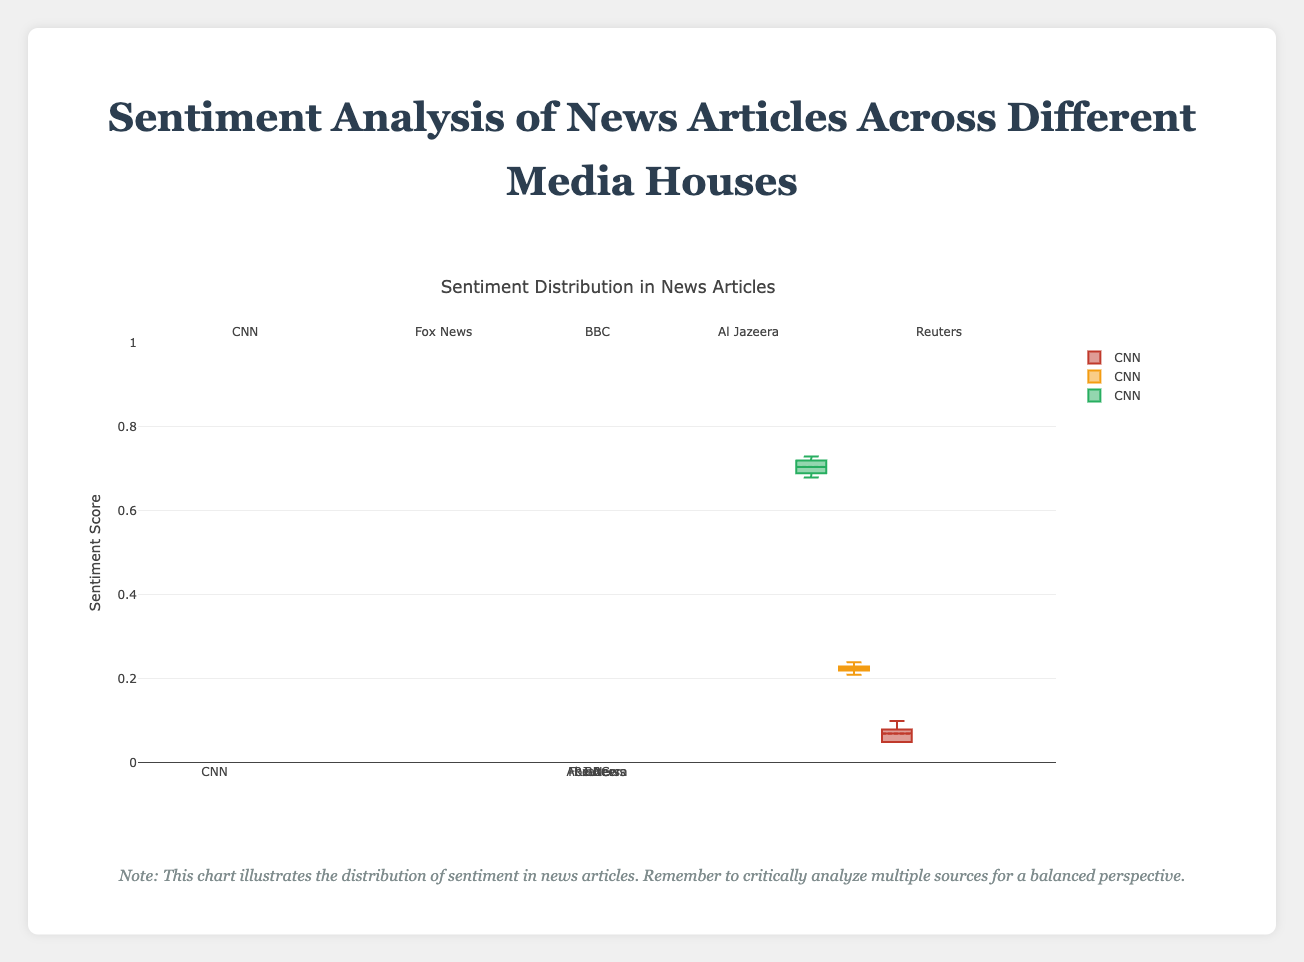What does the title of the chart indicate? The title of the chart is "Sentiment Analysis of News Articles Across Different Media Houses." This indicates that the chart shows the distribution of sentiment (positive, neutral, negative) in news articles from different media houses.
Answer: Sentiment Analysis of News Articles Across Different Media Houses What do the colors green, orange, and red represent in the box plot? In the box plot, the colors represent different sentiments: green represents positive sentiment, orange represents neutral sentiment, and red represents negative sentiment.
Answer: Positive, Neutral, Negative Which media house has the highest median positive sentiment score? To determine the highest median positive sentiment score, look at the middle line inside the green boxes for each media house. Reuters has the highest median positive sentiment score, as its middle line is the highest among all the green boxes.
Answer: Reuters Which media house has the widest range of negative sentiment scores? To find the widest range of negative sentiment scores, compare the length of the red boxes. CNN has the widest range as its red box spans a broader area than other media houses.
Answer: CNN How does the median neutral sentiment score for Fox News compare to CNN? Look at the middle line inside the orange boxes for both Fox News and CNN. The middle line (median) for Fox News’s neutral sentiment is slightly lower than CNN’s.
Answer: Fox News's median is lower What is the interquartile range (IQR) of positive sentiment scores for BBC? The IQR is the range between the first quartile (bottom of the box) and the third quartile (top of the box). For BBC's positive sentiment, the box plot extends from around 0.68 to 0.71. The IQR is 0.71 - 0.68 = 0.03.
Answer: 0.03 Which media house shows the least variability in neutral sentiment scores? Look for the shortest box in the orange category, which indicates less variability. Reuters shows the least variability in neutral sentiment scores as its orange box is the shortest.
Answer: Reuters How does the spread of positive sentiment scores for Al Jazeera compare to BBC? Compare the lengths of the green boxes for both media houses. The green box for Al Jazeera is longer than BBC’s, indicating a higher spread (more variability) in positive sentiment scores for Al Jazeera.
Answer: Al Jazeera has higher spread What can be inferred about the overall sentiment distribution in BBC's news articles compared to other media houses? Based on the box plots, BBC has positive sentiment scores clustered around a high median with a narrow range and consistently low negative sentiment scores, indicating positive and consistent sentiment in their articles compared to other media houses.
Answer: Positive and consistent What does a filled circle outside the box (an outlier) signify in the context of sentiment analysis? A filled circle outside the box represents an outlier, which is a sentiment score that is significantly different from the other scores in the dataset. It indicates articles with sentiment scores that deviate from the general trend.
Answer: Significant deviation 